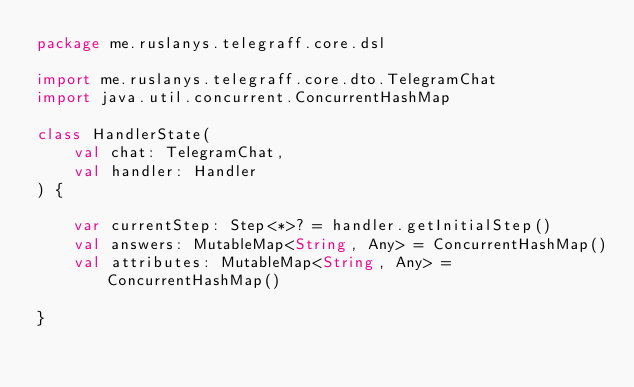<code> <loc_0><loc_0><loc_500><loc_500><_Kotlin_>package me.ruslanys.telegraff.core.dsl

import me.ruslanys.telegraff.core.dto.TelegramChat
import java.util.concurrent.ConcurrentHashMap

class HandlerState(
    val chat: TelegramChat,
    val handler: Handler
) {

    var currentStep: Step<*>? = handler.getInitialStep()
    val answers: MutableMap<String, Any> = ConcurrentHashMap()
    val attributes: MutableMap<String, Any> = ConcurrentHashMap()

}</code> 